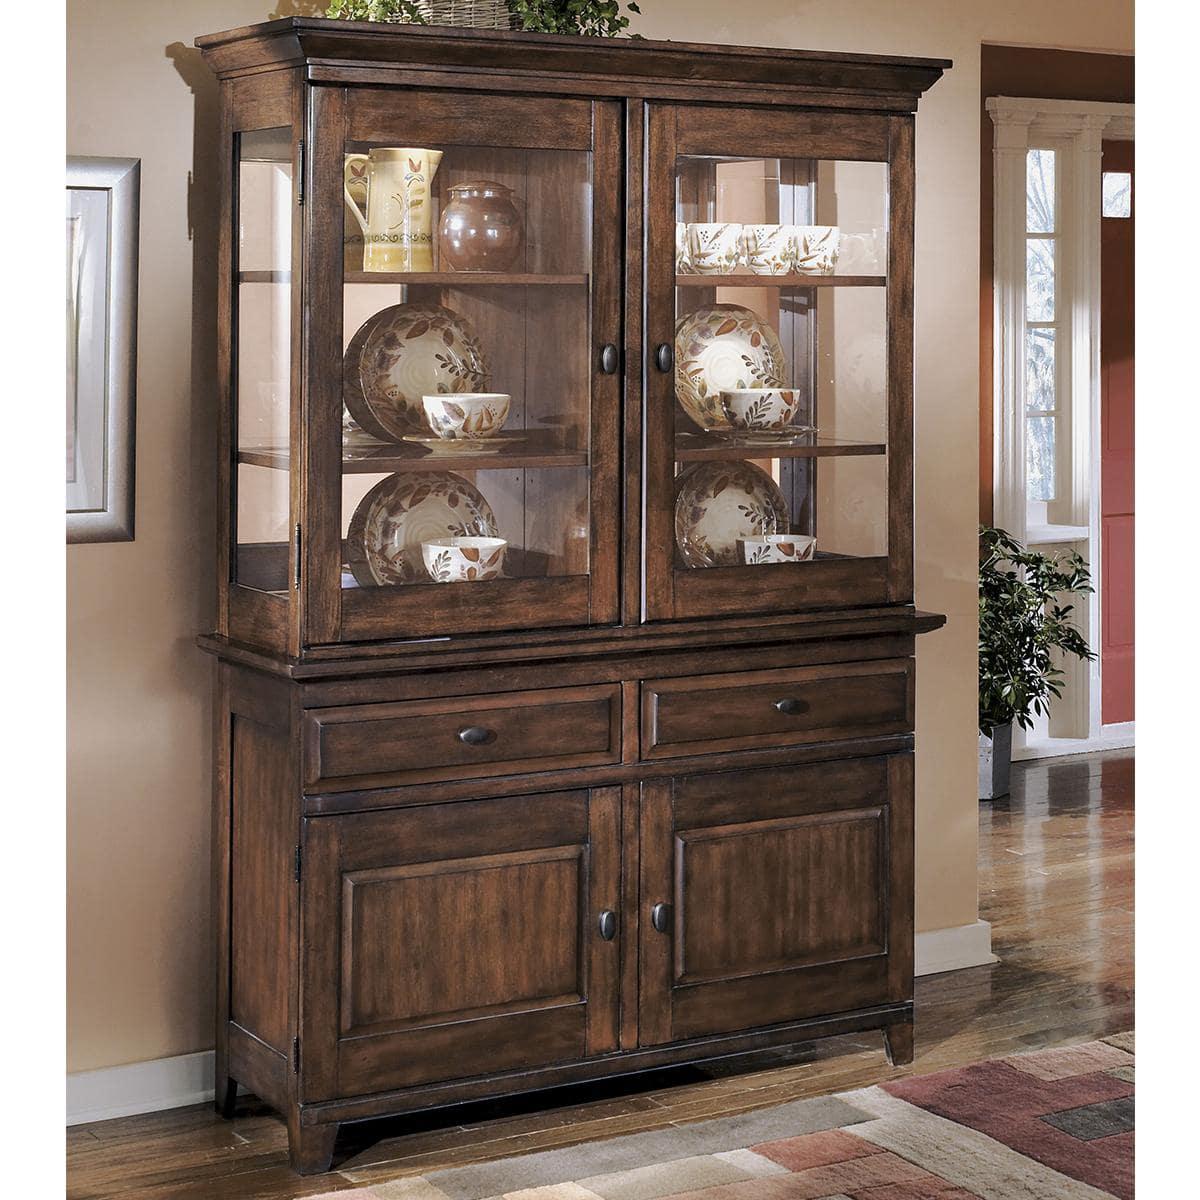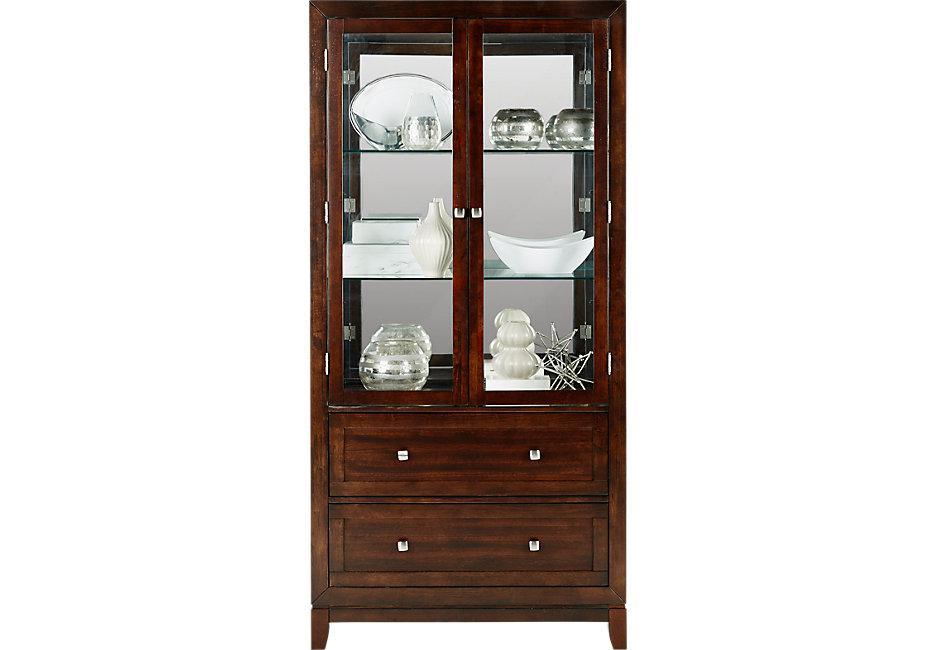The first image is the image on the left, the second image is the image on the right. Examine the images to the left and right. Is the description "There are two drawers on the cabinet in the image on the left." accurate? Answer yes or no. Yes. 